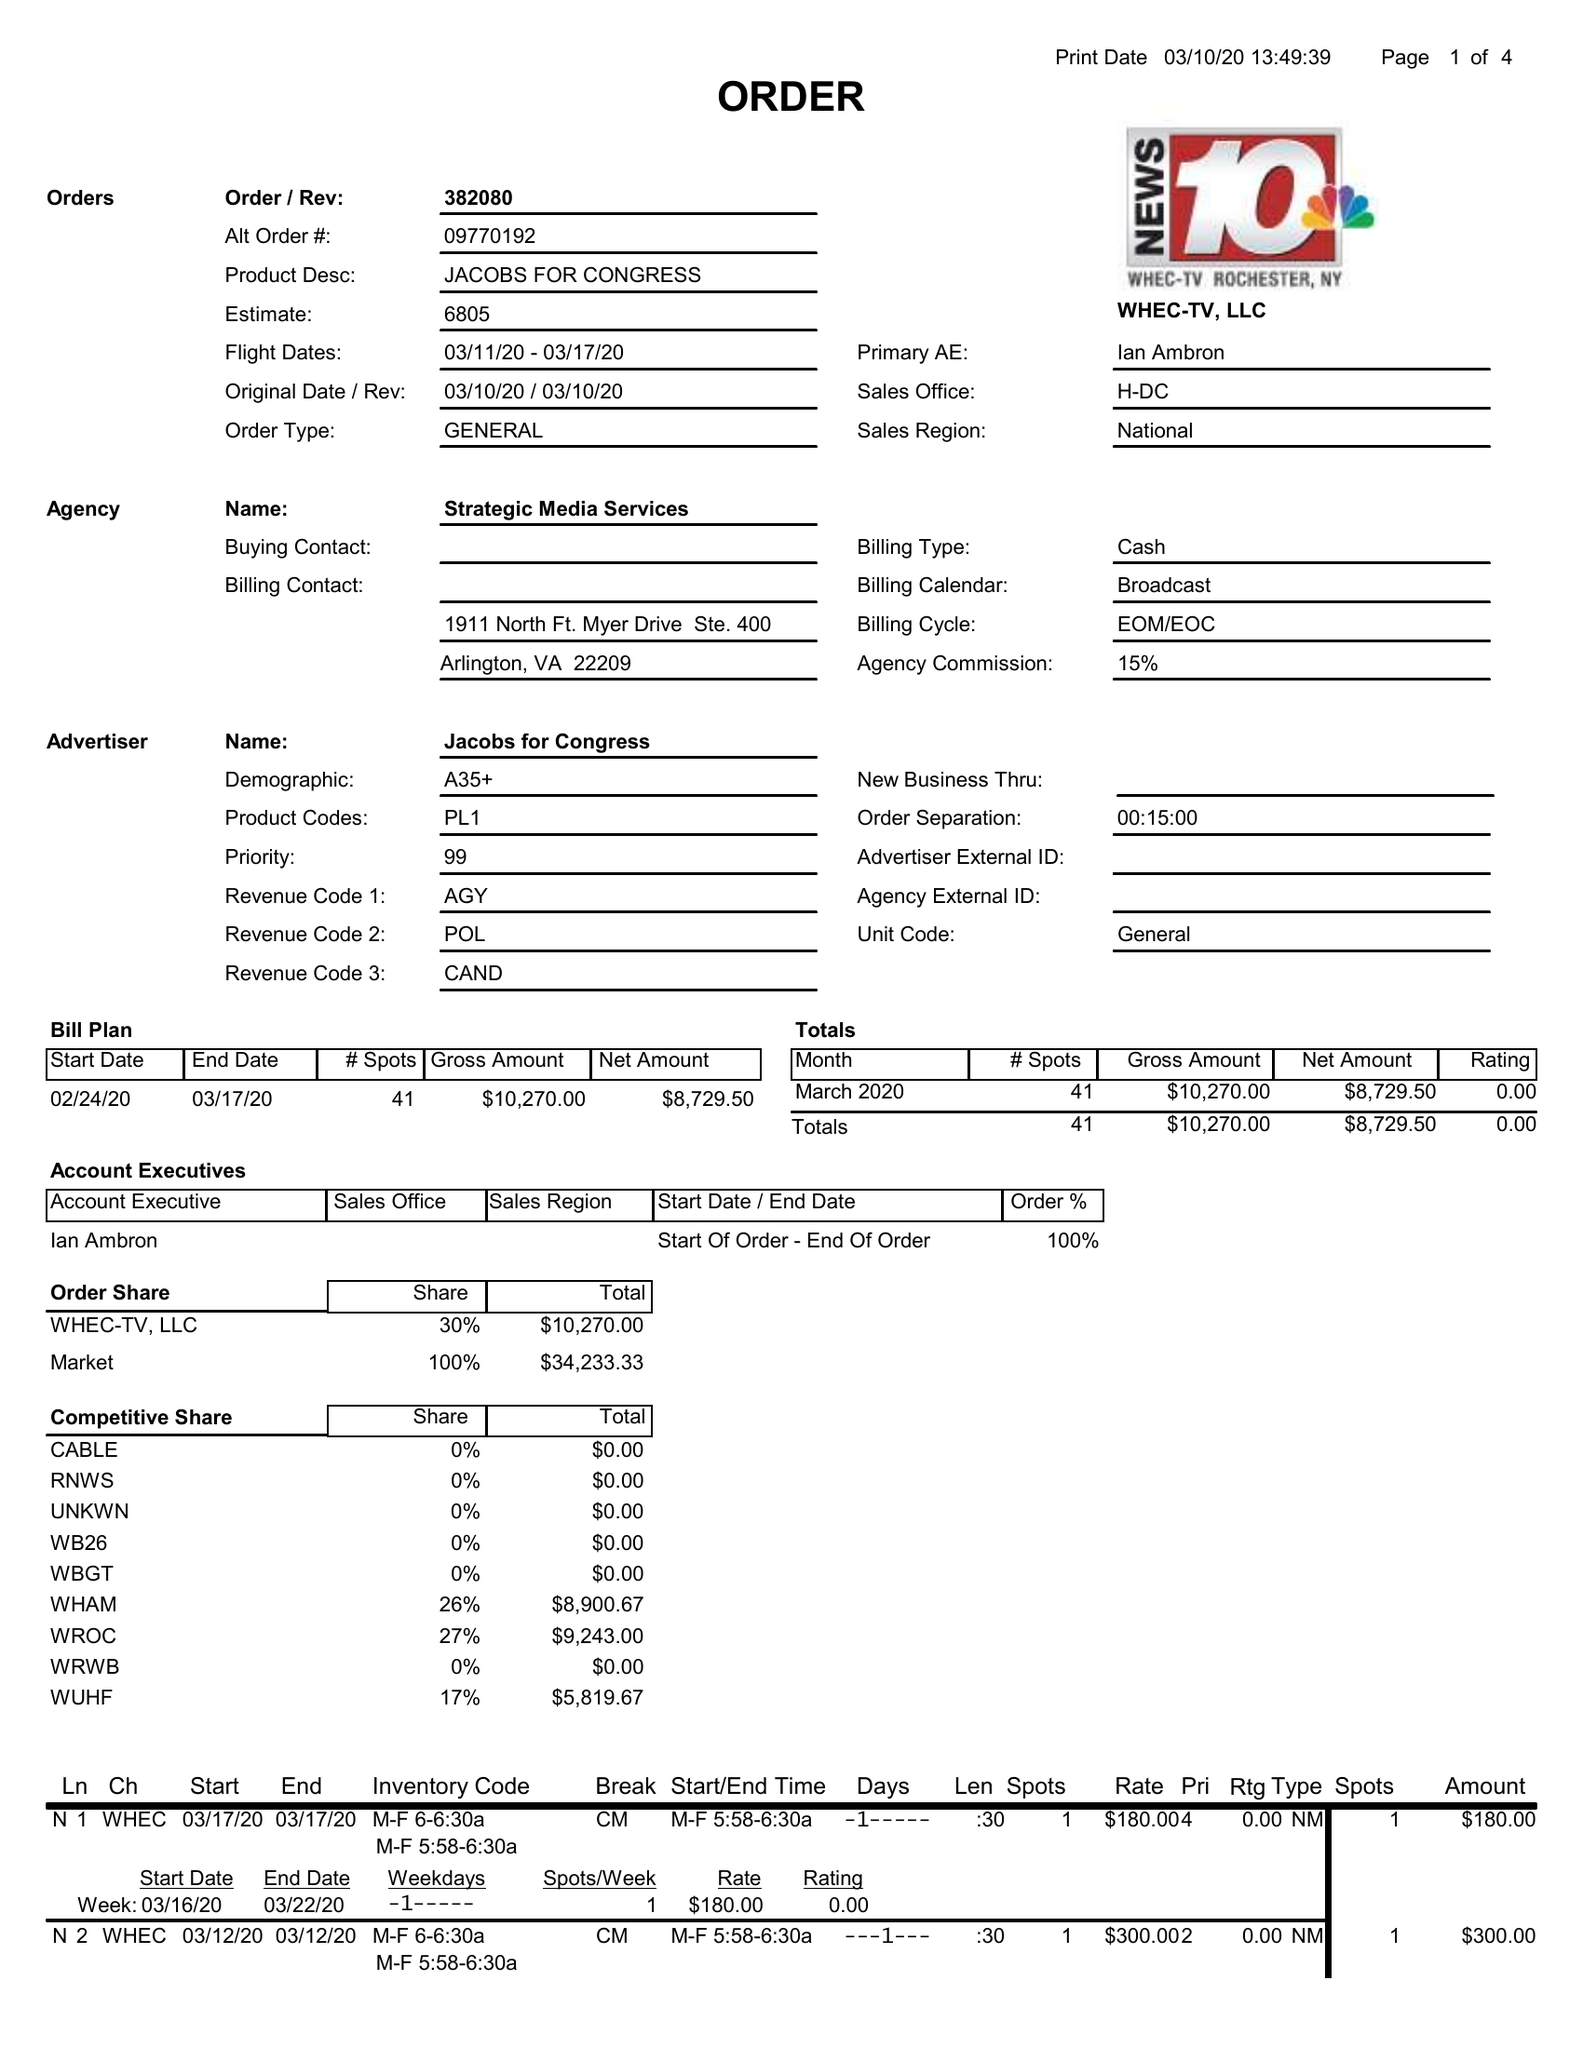What is the value for the flight_to?
Answer the question using a single word or phrase. 03/17/20 